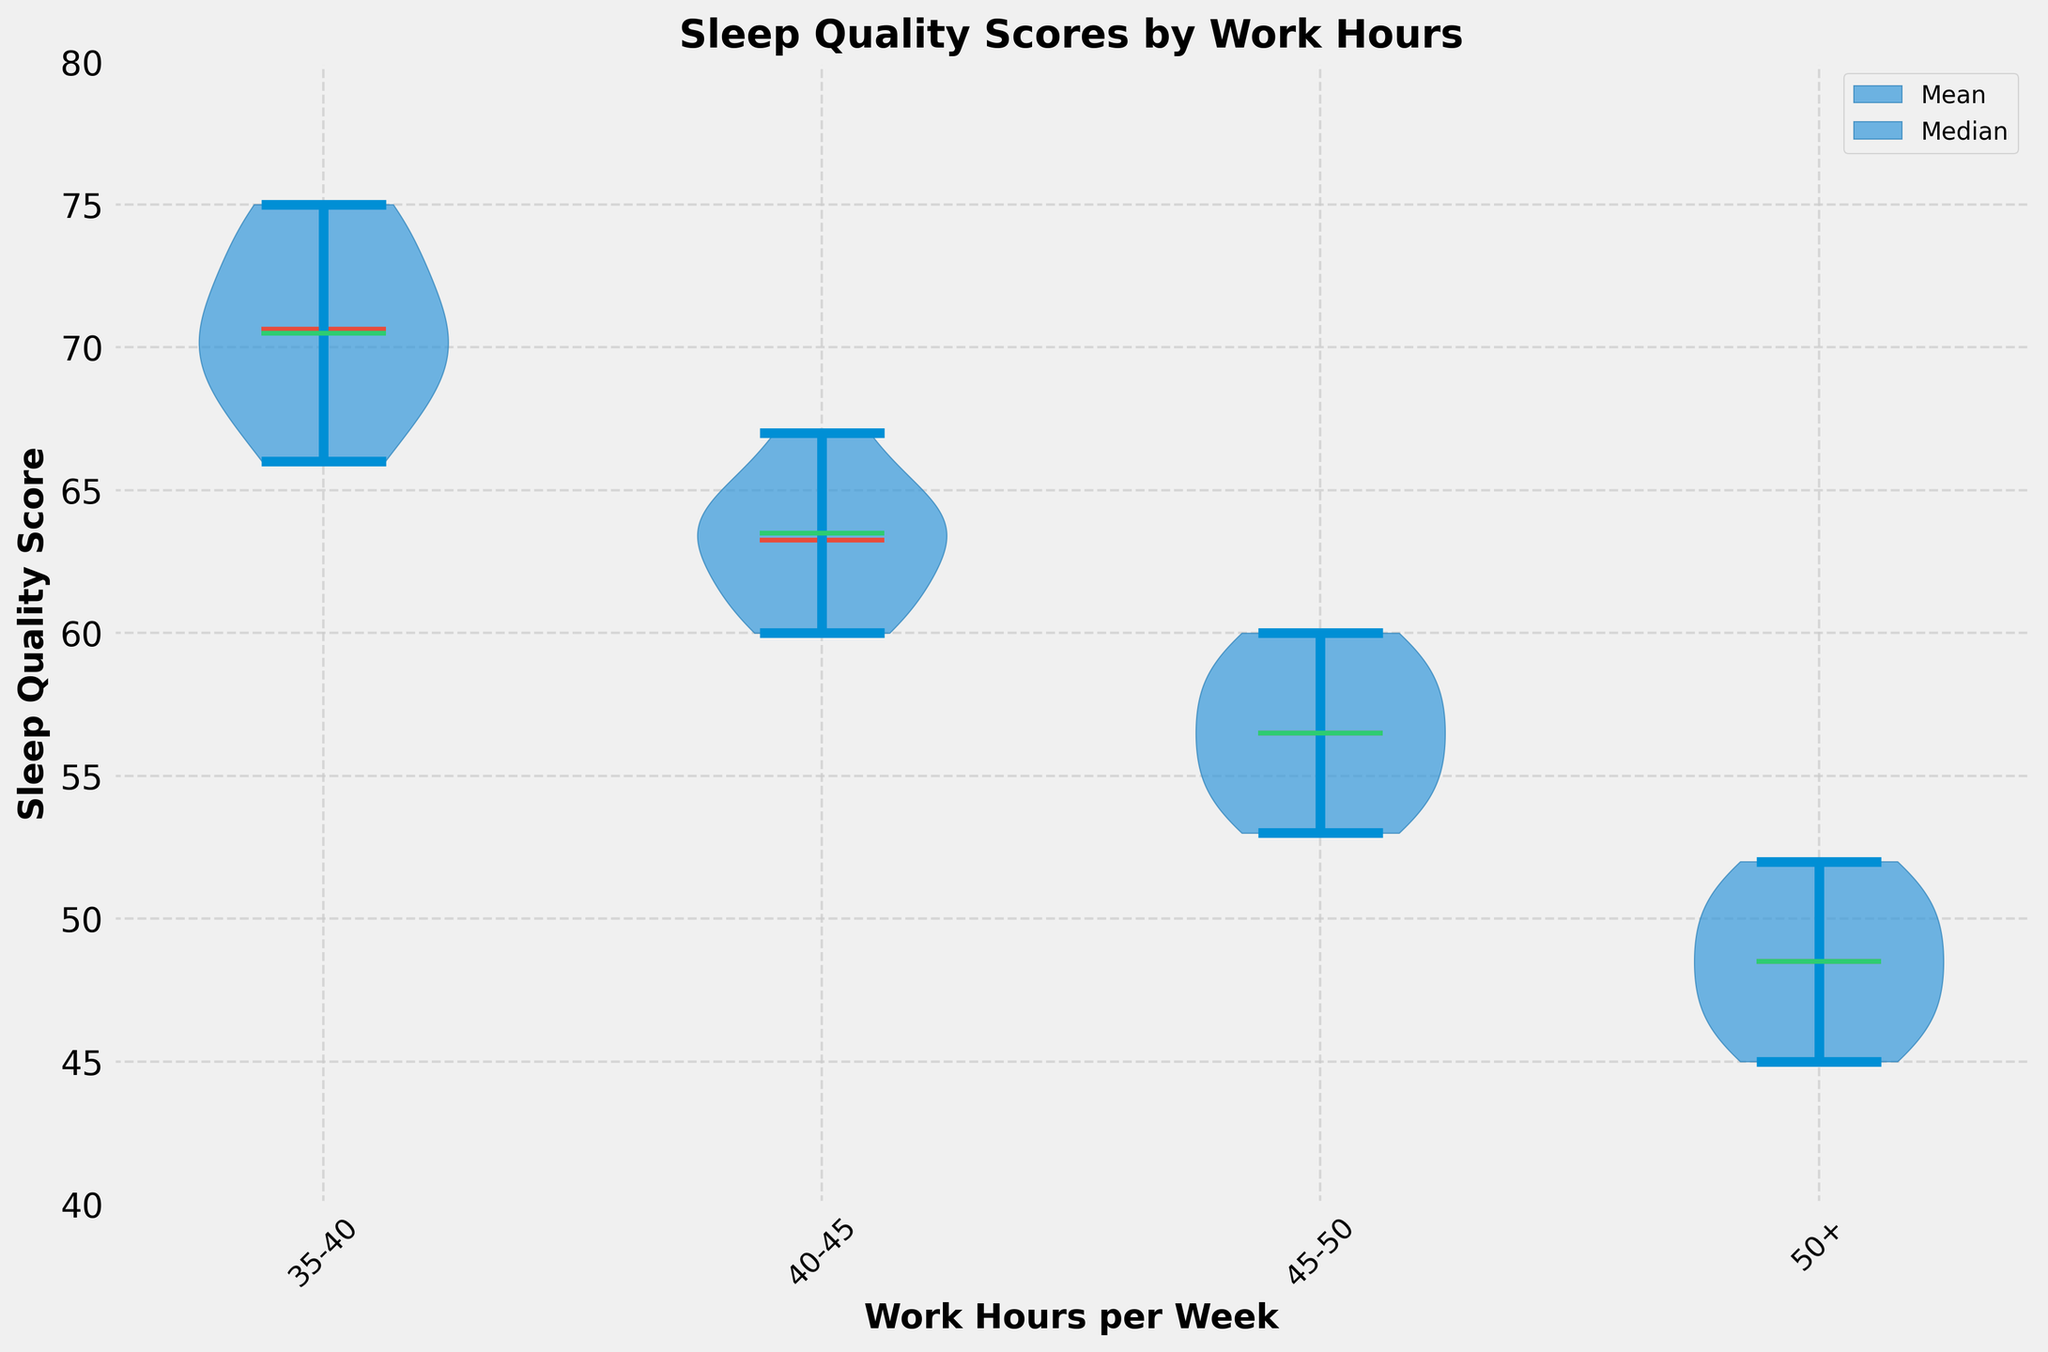What is the title of the figure? The title is displayed at the top of the figure in bold text. It reads "Sleep Quality Scores by Work Hours".
Answer: Sleep Quality Scores by Work Hours What is the color of the means line in the plot? The color of the means line is distinct and stands out. It is colored in red.
Answer: Red Which group has the highest median sleep quality score? Inspect the line representing the medians (green color) for each group. The highest median line appears in the "35-40" work hours group.
Answer: 35-40 What is the range of the y-axis? Look at the numerical labels on the y-axis on the left side of the plot. The range is from 40 to 80.
Answer: 40 to 80 How does the median sleep quality score for the '45-50' work hours group compare to the '50+' work hours group? Compare the green lines representing medians for both groups. The '45-50' median is higher than the '50+' median.
Answer: '45-50' is higher What work hours group has the widest distribution of sleep quality scores? Assess the width of the violin plots. The group with the widest violin plot is the '35-40' work hours group, indicating the widest distribution.
Answer: 35-40 What is the average sleep quality score range for the '40-45' work hours group? Observe the '40-45' violin plot. The range can be estimated from the top and bottom of this violin plot, which is from approximately 60 to 67.
Answer: 60 to 67 Which group shows the lowest sleep quality score reported? Look at the lowest point in all the violin plots. The '50+' hours group has the lowest score, which goes down to 45.
Answer: 50+ What is the color of the violin plots? The violin plot's main body has a specific color that is noted in the figure. It is a shade of blue.
Answer: Blue 